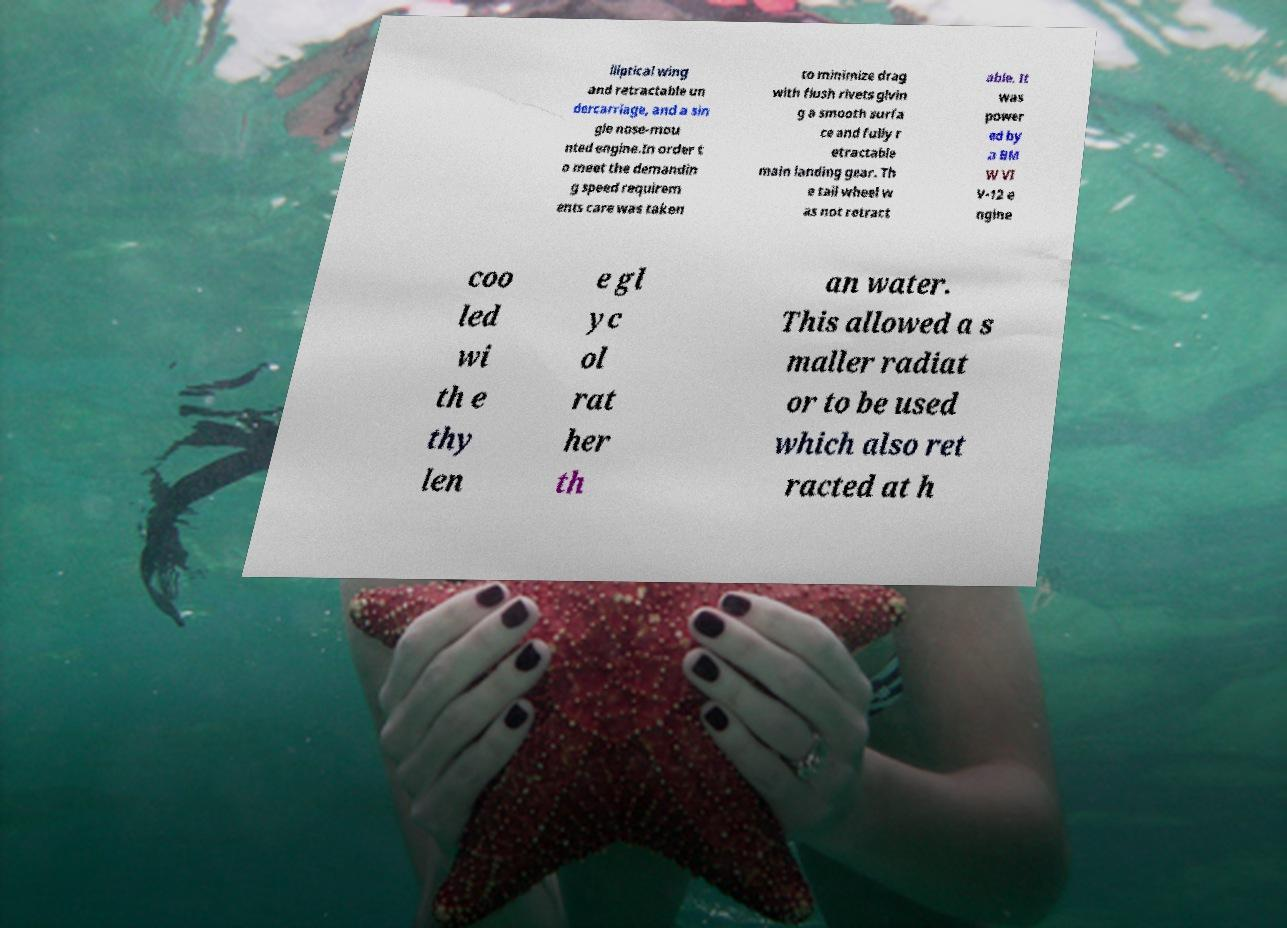Please read and relay the text visible in this image. What does it say? lliptical wing and retractable un dercarriage, and a sin gle nose-mou nted engine.In order t o meet the demandin g speed requirem ents care was taken to minimize drag with flush rivets givin g a smooth surfa ce and fully r etractable main landing gear. Th e tail wheel w as not retract able. It was power ed by a BM W VI V-12 e ngine coo led wi th e thy len e gl yc ol rat her th an water. This allowed a s maller radiat or to be used which also ret racted at h 